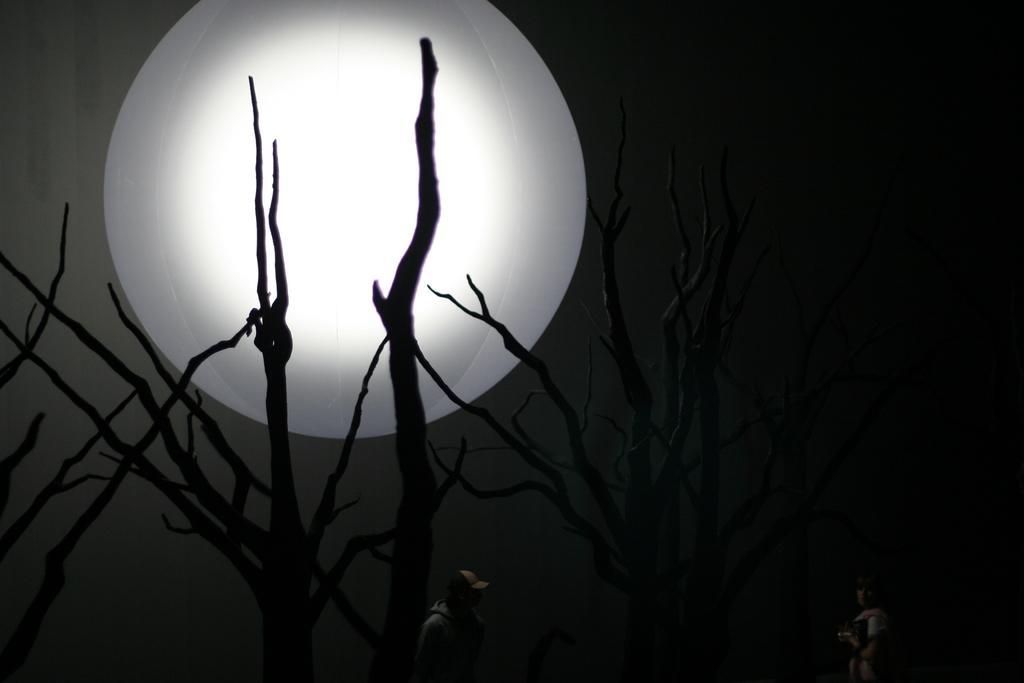Please provide a concise description of this image. These are the branches. This looks like an artificial moon in the sky. At the bottom of the image, there are two people standing. 